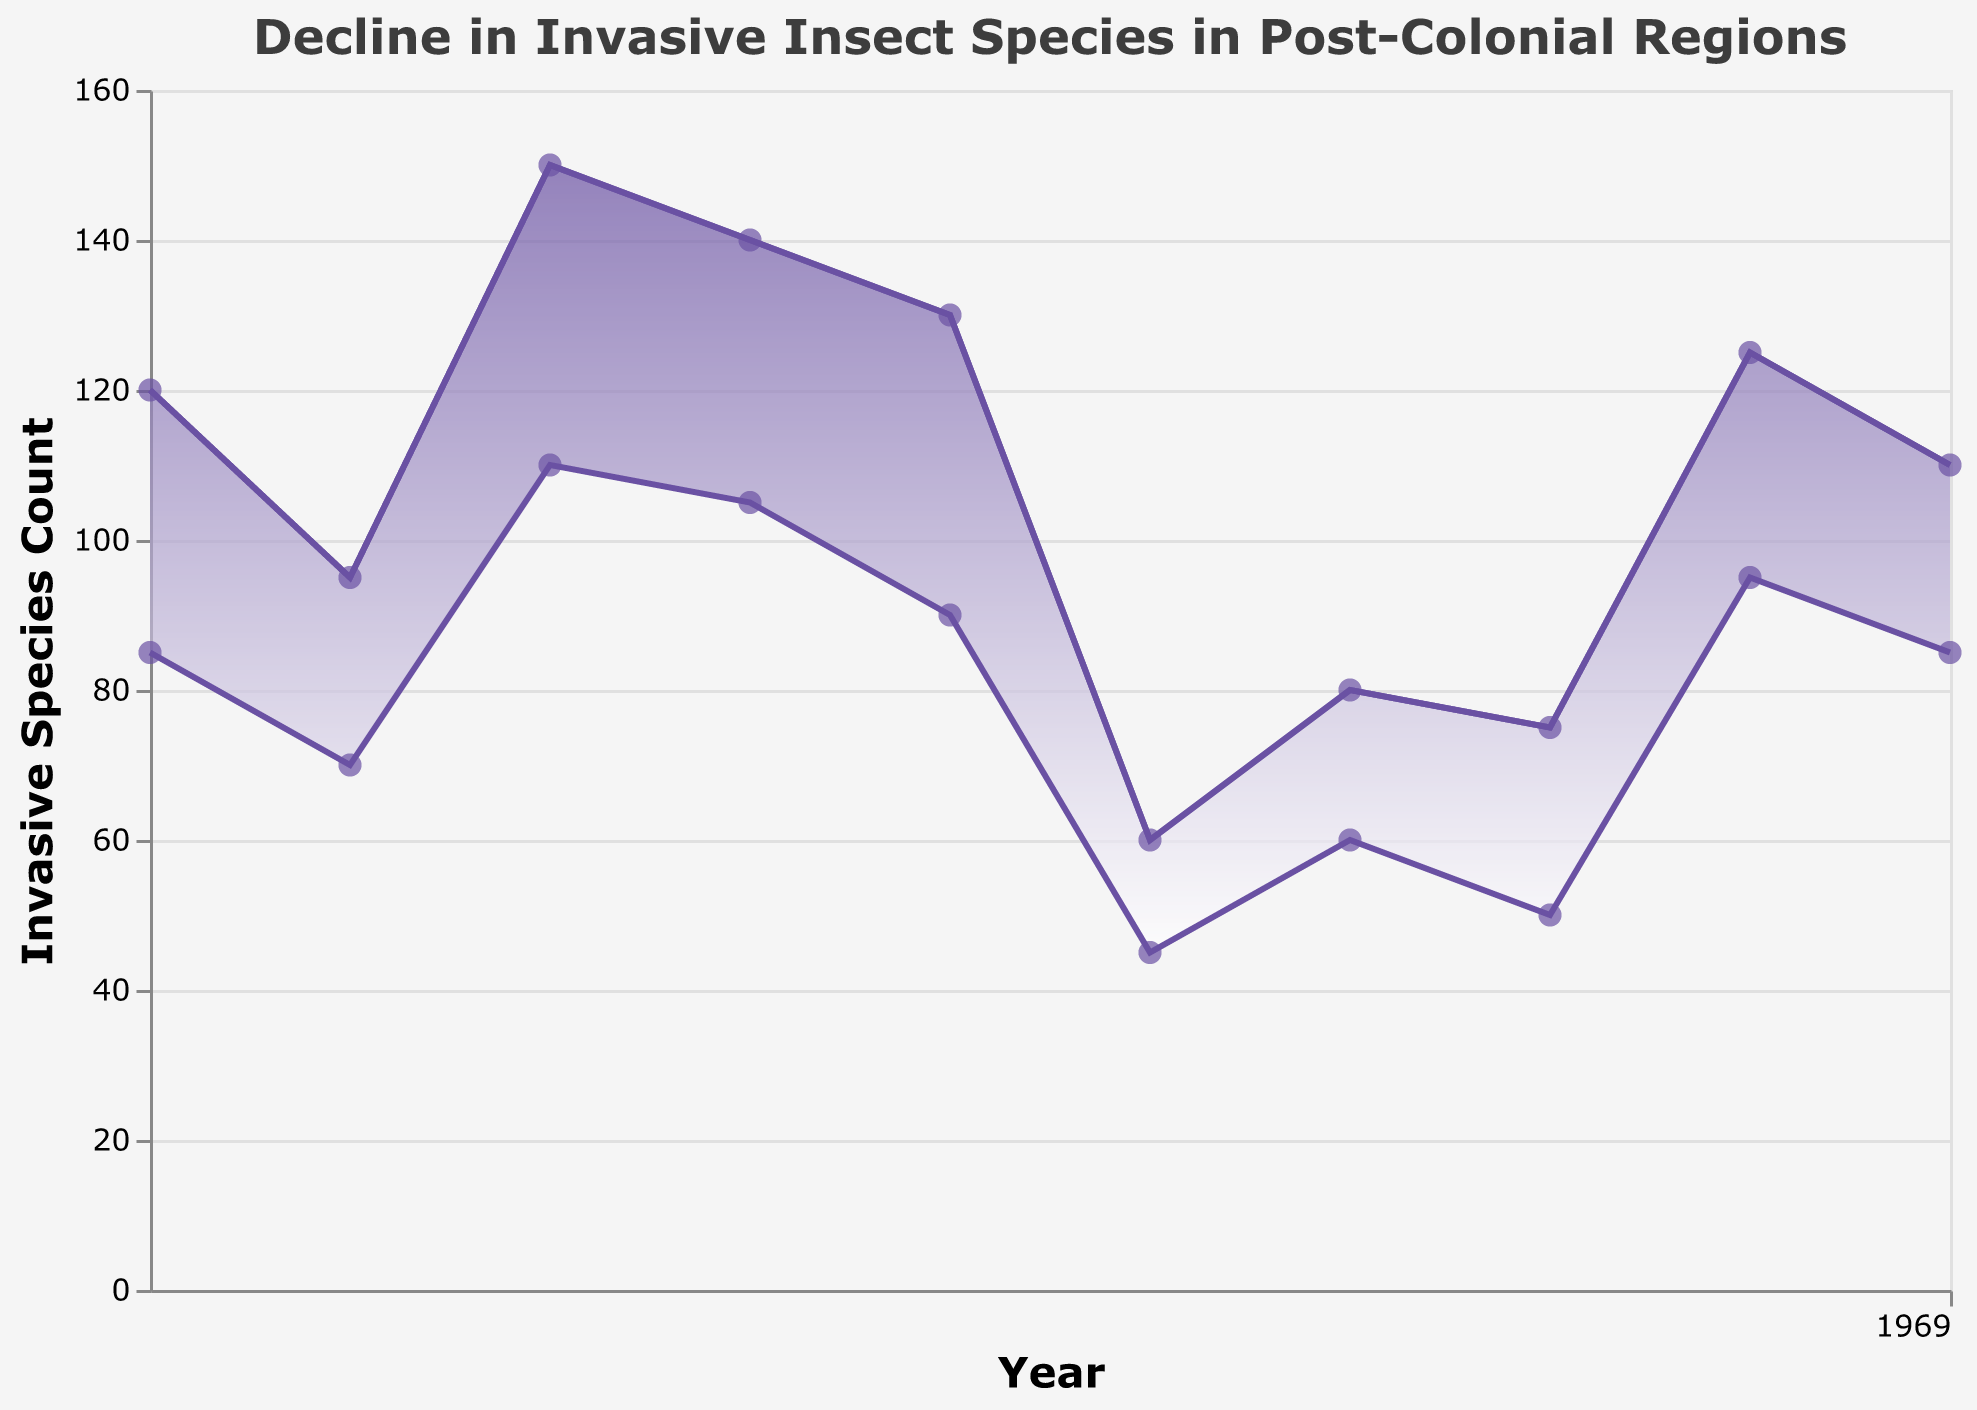How many regions are shown in the figure? Count the number of regions mentioned in the tooltip for different years.
Answer: 10 What is the highest count of invasive species before the policies were implemented? Look at the invasive species count before policies for all the regions and identify the maximum value.
Answer: 150 What is the average reduction in invasive species count across all regions? Calculate the difference between Before and After counts for each region, sum these differences, and divide by the number of regions: ((120-85) + (95-70) + (150-110) + (140-105) + (130-90) + (60-45) + (80-60) + (75-50) + (125-95) + (110-85)) / 10 = (35 + 25 + 40 + 35 + 40 + 15 + 20 + 25 + 30 + 25) / 10 = 290 / 10 = 29
Answer: 29 Which region saw the largest decrease in invasive species count? Subtract the after policy count from the before policy count for each region and identify the region with the highest decrease.
Answer: South Africa (150 - 110 = 40) How did the invasive species count change over the years in South Africa? Trace the invasive species count for South Africa before and after the policy and narrate the change.
Answer: Decreased from 150 to 110 In which year did Nigeria implement their conservation policy? Locate Nigeria in the tooltip and check the corresponding year.
Answer: 2009 Compare the invasive species counts before and after policy implementation for Brazil and Mexico. Which country shows a larger reduction? Calculate the reduction for both countries (Brazil: 140-105, Mexico: 80-60) and compare the values.
Answer: Brazil (35) What conservation policy was implemented by Australia? Refer to the tooltip for Australia to find the policy name.
Answer: National Weeds and Pest Animals Control Programme Which region had the smallest number of invasive species before the policies were implemented? Look at the invasive species count before policies for all the regions and identify the minimum value.
Answer: Canada (60) How does the general trend of invasive species count before and after policy implementation appear in the figure? Observe the overall area between the "before" and "after" lines. Notice the general decrease in the purple area representing the count reduction.
Answer: General decrease 